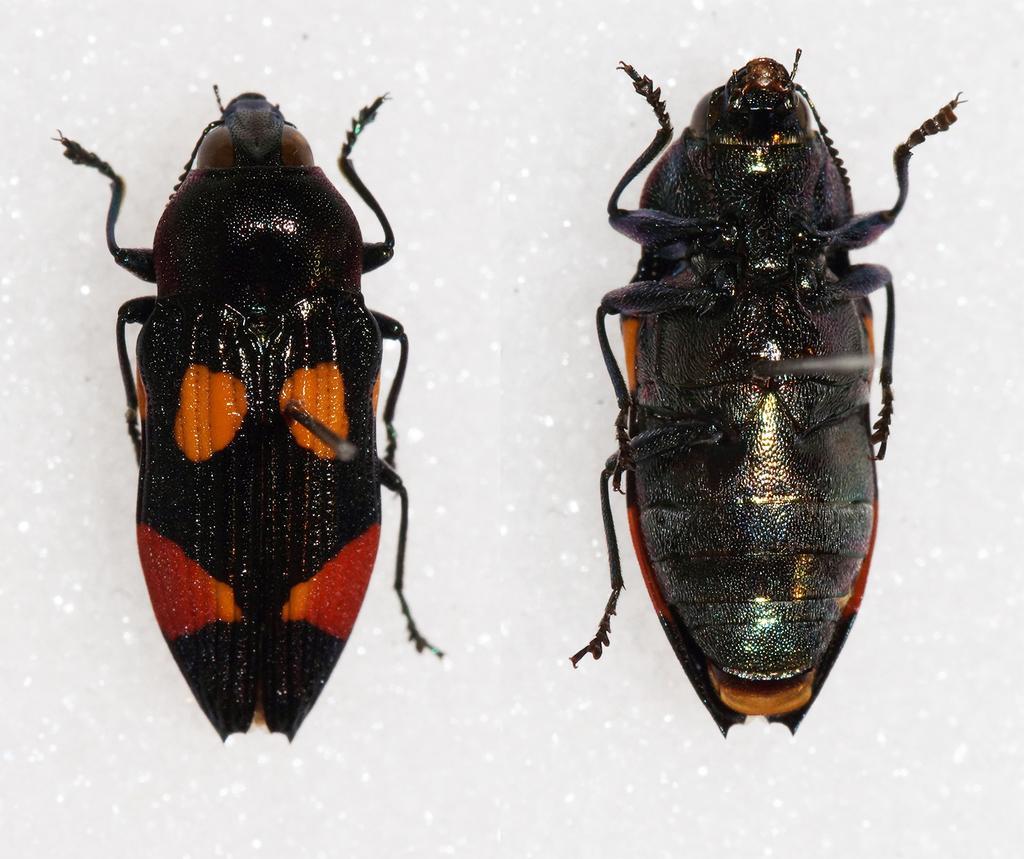Could you give a brief overview of what you see in this image? In this image we can see two insects and a white background. 